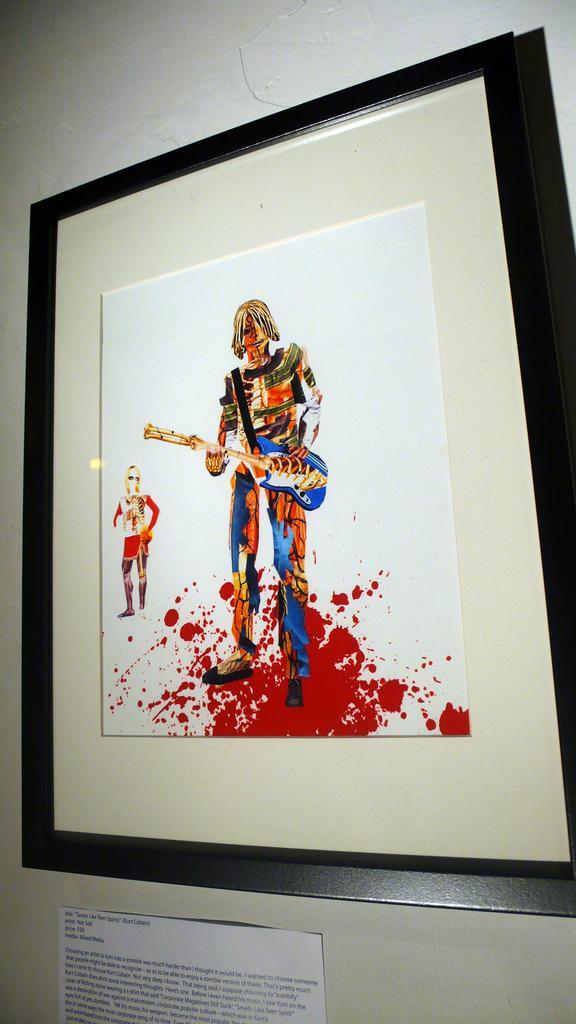Describe this image in one or two sentences. In this image there is a painted photo to the frame and the frame is attached to the wall and there is also a paper to the wall. 